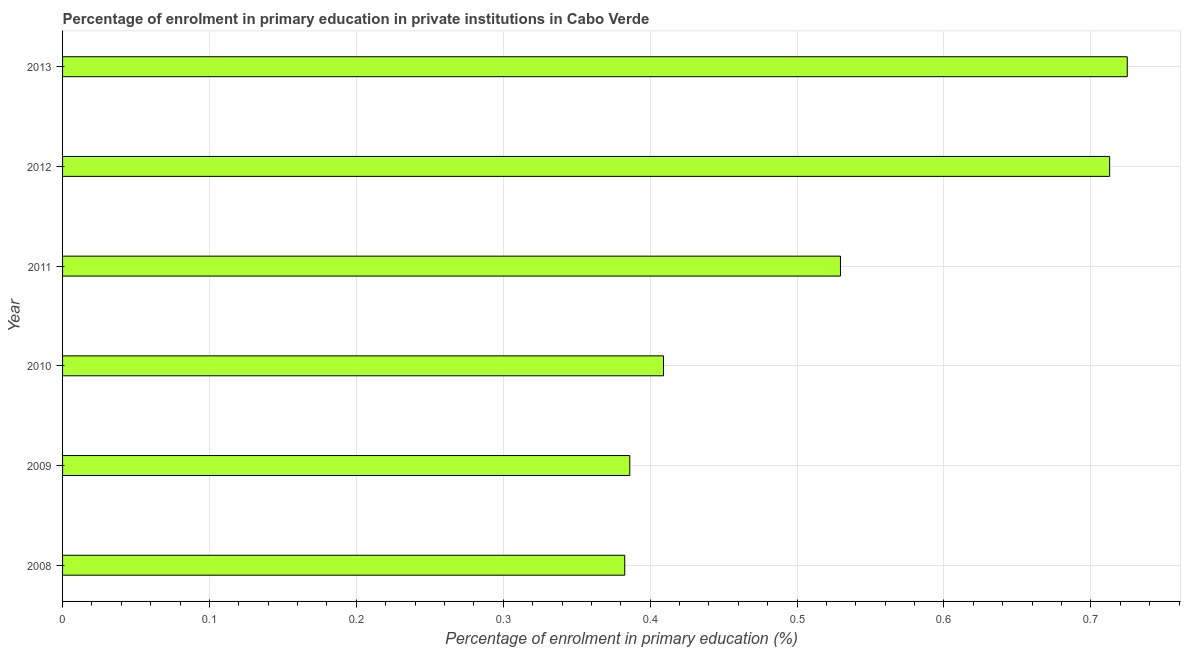Does the graph contain grids?
Provide a short and direct response. Yes. What is the title of the graph?
Provide a succinct answer. Percentage of enrolment in primary education in private institutions in Cabo Verde. What is the label or title of the X-axis?
Offer a very short reply. Percentage of enrolment in primary education (%). What is the enrolment percentage in primary education in 2013?
Your answer should be compact. 0.72. Across all years, what is the maximum enrolment percentage in primary education?
Make the answer very short. 0.72. Across all years, what is the minimum enrolment percentage in primary education?
Provide a succinct answer. 0.38. What is the sum of the enrolment percentage in primary education?
Offer a very short reply. 3.15. What is the difference between the enrolment percentage in primary education in 2010 and 2011?
Give a very brief answer. -0.12. What is the average enrolment percentage in primary education per year?
Keep it short and to the point. 0.52. What is the median enrolment percentage in primary education?
Provide a short and direct response. 0.47. What is the ratio of the enrolment percentage in primary education in 2009 to that in 2011?
Your answer should be very brief. 0.73. Is the enrolment percentage in primary education in 2008 less than that in 2013?
Offer a terse response. Yes. Is the difference between the enrolment percentage in primary education in 2010 and 2011 greater than the difference between any two years?
Your answer should be compact. No. What is the difference between the highest and the second highest enrolment percentage in primary education?
Provide a succinct answer. 0.01. Is the sum of the enrolment percentage in primary education in 2010 and 2013 greater than the maximum enrolment percentage in primary education across all years?
Provide a succinct answer. Yes. What is the difference between the highest and the lowest enrolment percentage in primary education?
Your answer should be compact. 0.34. In how many years, is the enrolment percentage in primary education greater than the average enrolment percentage in primary education taken over all years?
Your response must be concise. 3. How many years are there in the graph?
Provide a short and direct response. 6. What is the difference between two consecutive major ticks on the X-axis?
Make the answer very short. 0.1. Are the values on the major ticks of X-axis written in scientific E-notation?
Your response must be concise. No. What is the Percentage of enrolment in primary education (%) in 2008?
Your answer should be very brief. 0.38. What is the Percentage of enrolment in primary education (%) in 2009?
Ensure brevity in your answer.  0.39. What is the Percentage of enrolment in primary education (%) of 2010?
Ensure brevity in your answer.  0.41. What is the Percentage of enrolment in primary education (%) in 2011?
Offer a terse response. 0.53. What is the Percentage of enrolment in primary education (%) in 2012?
Give a very brief answer. 0.71. What is the Percentage of enrolment in primary education (%) of 2013?
Keep it short and to the point. 0.72. What is the difference between the Percentage of enrolment in primary education (%) in 2008 and 2009?
Keep it short and to the point. -0. What is the difference between the Percentage of enrolment in primary education (%) in 2008 and 2010?
Give a very brief answer. -0.03. What is the difference between the Percentage of enrolment in primary education (%) in 2008 and 2011?
Your answer should be compact. -0.15. What is the difference between the Percentage of enrolment in primary education (%) in 2008 and 2012?
Offer a very short reply. -0.33. What is the difference between the Percentage of enrolment in primary education (%) in 2008 and 2013?
Provide a short and direct response. -0.34. What is the difference between the Percentage of enrolment in primary education (%) in 2009 and 2010?
Your answer should be very brief. -0.02. What is the difference between the Percentage of enrolment in primary education (%) in 2009 and 2011?
Make the answer very short. -0.14. What is the difference between the Percentage of enrolment in primary education (%) in 2009 and 2012?
Provide a short and direct response. -0.33. What is the difference between the Percentage of enrolment in primary education (%) in 2009 and 2013?
Provide a short and direct response. -0.34. What is the difference between the Percentage of enrolment in primary education (%) in 2010 and 2011?
Give a very brief answer. -0.12. What is the difference between the Percentage of enrolment in primary education (%) in 2010 and 2012?
Provide a succinct answer. -0.3. What is the difference between the Percentage of enrolment in primary education (%) in 2010 and 2013?
Your answer should be very brief. -0.32. What is the difference between the Percentage of enrolment in primary education (%) in 2011 and 2012?
Offer a very short reply. -0.18. What is the difference between the Percentage of enrolment in primary education (%) in 2011 and 2013?
Your response must be concise. -0.2. What is the difference between the Percentage of enrolment in primary education (%) in 2012 and 2013?
Provide a succinct answer. -0.01. What is the ratio of the Percentage of enrolment in primary education (%) in 2008 to that in 2009?
Your answer should be very brief. 0.99. What is the ratio of the Percentage of enrolment in primary education (%) in 2008 to that in 2010?
Offer a terse response. 0.94. What is the ratio of the Percentage of enrolment in primary education (%) in 2008 to that in 2011?
Provide a succinct answer. 0.72. What is the ratio of the Percentage of enrolment in primary education (%) in 2008 to that in 2012?
Provide a succinct answer. 0.54. What is the ratio of the Percentage of enrolment in primary education (%) in 2008 to that in 2013?
Offer a very short reply. 0.53. What is the ratio of the Percentage of enrolment in primary education (%) in 2009 to that in 2010?
Give a very brief answer. 0.94. What is the ratio of the Percentage of enrolment in primary education (%) in 2009 to that in 2011?
Offer a terse response. 0.73. What is the ratio of the Percentage of enrolment in primary education (%) in 2009 to that in 2012?
Your answer should be very brief. 0.54. What is the ratio of the Percentage of enrolment in primary education (%) in 2009 to that in 2013?
Offer a terse response. 0.53. What is the ratio of the Percentage of enrolment in primary education (%) in 2010 to that in 2011?
Provide a succinct answer. 0.77. What is the ratio of the Percentage of enrolment in primary education (%) in 2010 to that in 2012?
Offer a terse response. 0.57. What is the ratio of the Percentage of enrolment in primary education (%) in 2010 to that in 2013?
Your answer should be compact. 0.56. What is the ratio of the Percentage of enrolment in primary education (%) in 2011 to that in 2012?
Keep it short and to the point. 0.74. What is the ratio of the Percentage of enrolment in primary education (%) in 2011 to that in 2013?
Your response must be concise. 0.73. 